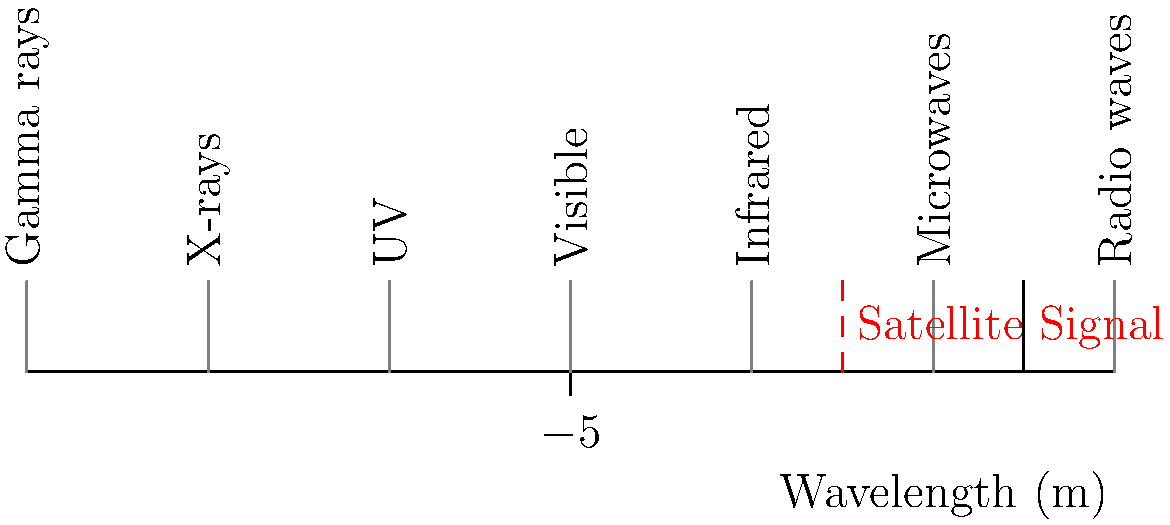During our satellite mission, we used specific frequencies for communication. Given the electromagnetic spectrum chart above, which region does our satellite signal fall into, and what is its approximate wavelength? To determine the region and approximate wavelength of the satellite signal, let's follow these steps:

1. Locate the red dashed line on the chart, which represents the satellite signal.

2. Identify the region: The red line falls in the "Microwaves" section of the electromagnetic spectrum.

3. Estimate the wavelength:
   - The x-axis represents wavelength in meters on a logarithmic scale.
   - The red line appears to be at $10^{-2}$ m or 1 cm.

4. Convert to frequency:
   - We can use the equation $c = f\lambda$, where:
     $c$ is the speed of light ($3 \times 10^8$ m/s)
     $f$ is frequency (Hz)
     $\lambda$ is wavelength (m)
   
   - Rearranging the equation: $f = \frac{c}{\lambda}$
   
   - Substituting values:
     $f = \frac{3 \times 10^8 \text{ m/s}}{10^{-2} \text{ m}} = 3 \times 10^{10} \text{ Hz} = 30 \text{ GHz}$

5. Verify: This frequency (30 GHz) falls within the typical range for satellite communications, which often use frequencies between 1 and 40 GHz.
Answer: Microwave region, wavelength ≈ 1 cm 